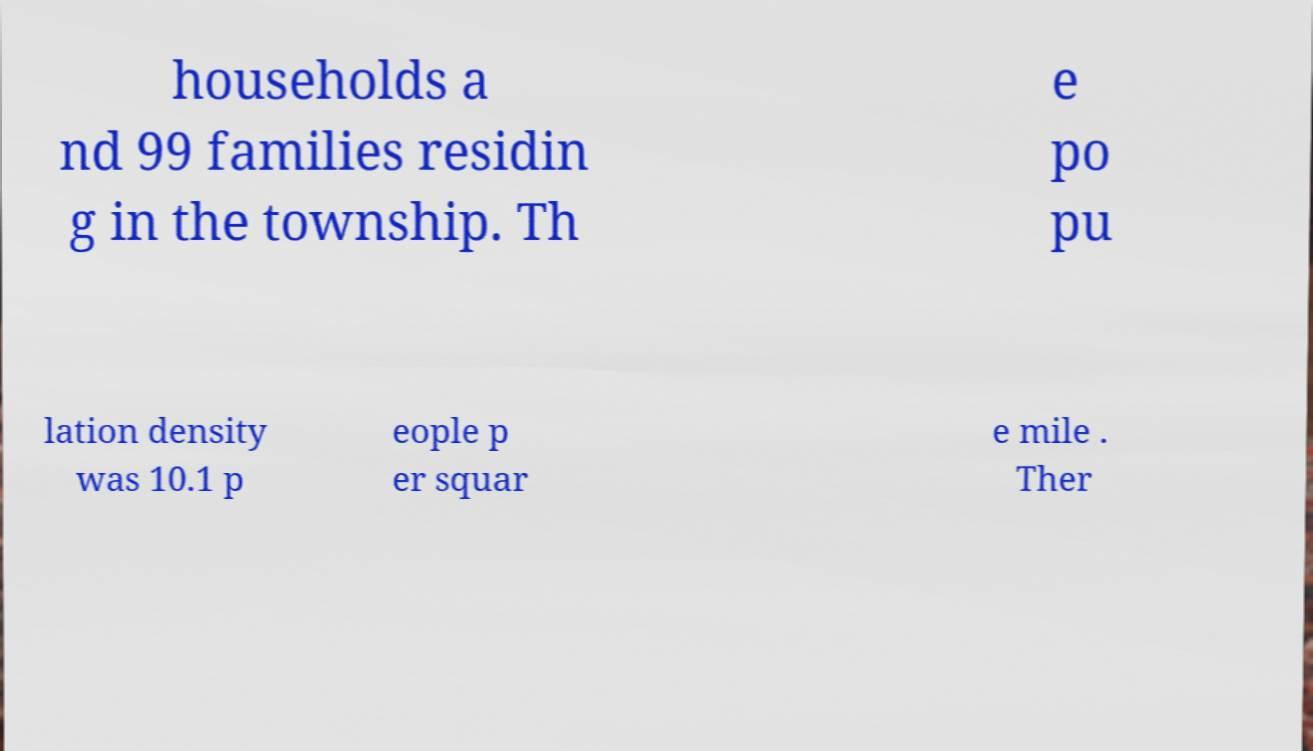What messages or text are displayed in this image? I need them in a readable, typed format. households a nd 99 families residin g in the township. Th e po pu lation density was 10.1 p eople p er squar e mile . Ther 